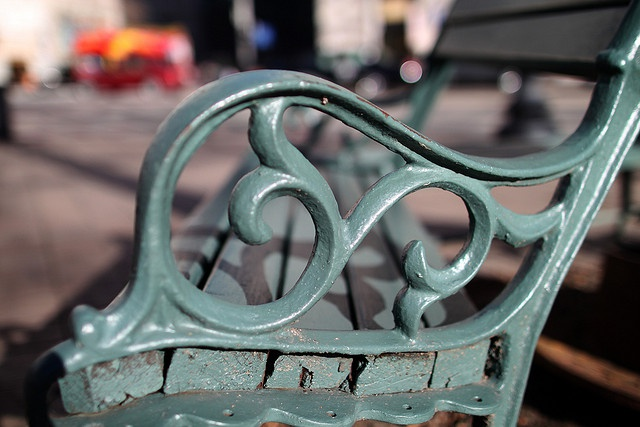Describe the objects in this image and their specific colors. I can see bench in white, gray, black, and darkgray tones and bus in white, maroon, brown, salmon, and orange tones in this image. 